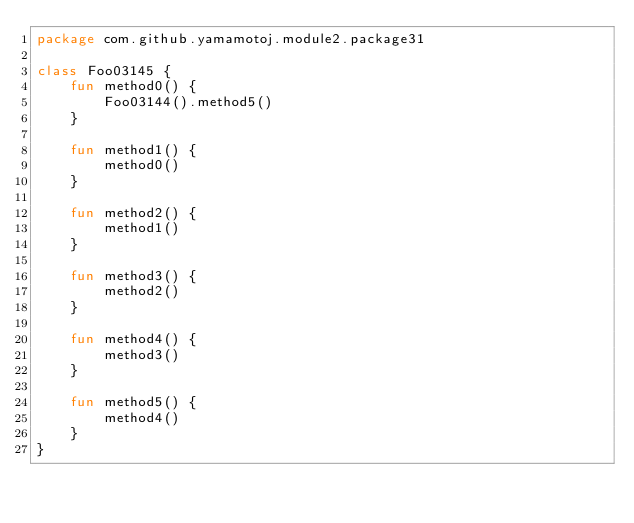<code> <loc_0><loc_0><loc_500><loc_500><_Kotlin_>package com.github.yamamotoj.module2.package31

class Foo03145 {
    fun method0() {
        Foo03144().method5()
    }

    fun method1() {
        method0()
    }

    fun method2() {
        method1()
    }

    fun method3() {
        method2()
    }

    fun method4() {
        method3()
    }

    fun method5() {
        method4()
    }
}
</code> 